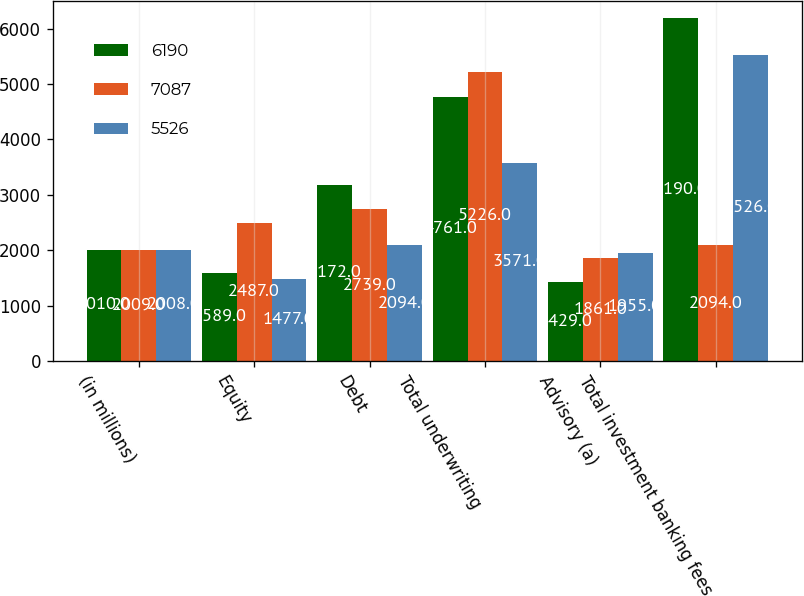Convert chart to OTSL. <chart><loc_0><loc_0><loc_500><loc_500><stacked_bar_chart><ecel><fcel>(in millions)<fcel>Equity<fcel>Debt<fcel>Total underwriting<fcel>Advisory (a)<fcel>Total investment banking fees<nl><fcel>6190<fcel>2010<fcel>1589<fcel>3172<fcel>4761<fcel>1429<fcel>6190<nl><fcel>7087<fcel>2009<fcel>2487<fcel>2739<fcel>5226<fcel>1861<fcel>2094<nl><fcel>5526<fcel>2008<fcel>1477<fcel>2094<fcel>3571<fcel>1955<fcel>5526<nl></chart> 